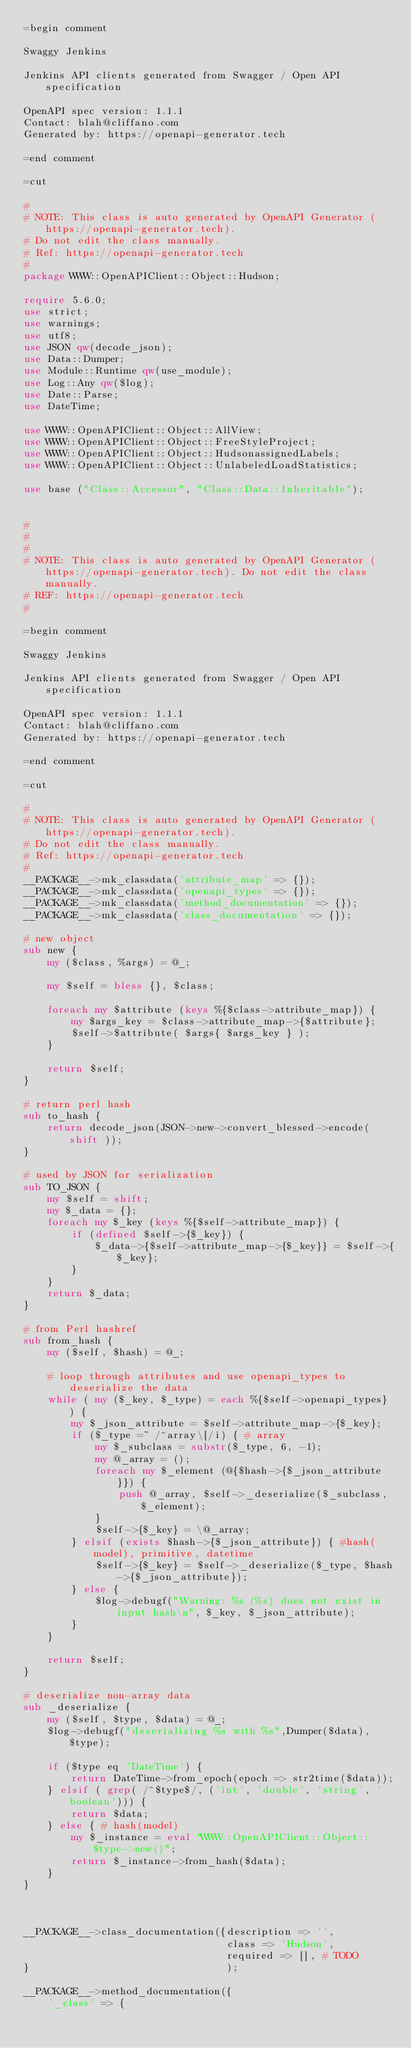<code> <loc_0><loc_0><loc_500><loc_500><_Perl_>=begin comment

Swaggy Jenkins

Jenkins API clients generated from Swagger / Open API specification

OpenAPI spec version: 1.1.1
Contact: blah@cliffano.com
Generated by: https://openapi-generator.tech

=end comment

=cut

#
# NOTE: This class is auto generated by OpenAPI Generator (https://openapi-generator.tech).
# Do not edit the class manually.
# Ref: https://openapi-generator.tech
#
package WWW::OpenAPIClient::Object::Hudson;

require 5.6.0;
use strict;
use warnings;
use utf8;
use JSON qw(decode_json);
use Data::Dumper;
use Module::Runtime qw(use_module);
use Log::Any qw($log);
use Date::Parse;
use DateTime;

use WWW::OpenAPIClient::Object::AllView;
use WWW::OpenAPIClient::Object::FreeStyleProject;
use WWW::OpenAPIClient::Object::HudsonassignedLabels;
use WWW::OpenAPIClient::Object::UnlabeledLoadStatistics;

use base ("Class::Accessor", "Class::Data::Inheritable");


#
#
#
# NOTE: This class is auto generated by OpenAPI Generator (https://openapi-generator.tech). Do not edit the class manually.
# REF: https://openapi-generator.tech
#

=begin comment

Swaggy Jenkins

Jenkins API clients generated from Swagger / Open API specification

OpenAPI spec version: 1.1.1
Contact: blah@cliffano.com
Generated by: https://openapi-generator.tech

=end comment

=cut

#
# NOTE: This class is auto generated by OpenAPI Generator (https://openapi-generator.tech).
# Do not edit the class manually.
# Ref: https://openapi-generator.tech
#
__PACKAGE__->mk_classdata('attribute_map' => {});
__PACKAGE__->mk_classdata('openapi_types' => {});
__PACKAGE__->mk_classdata('method_documentation' => {}); 
__PACKAGE__->mk_classdata('class_documentation' => {});

# new object
sub new { 
    my ($class, %args) = @_; 

	my $self = bless {}, $class;
	
	foreach my $attribute (keys %{$class->attribute_map}) {
		my $args_key = $class->attribute_map->{$attribute};
		$self->$attribute( $args{ $args_key } );
	}
	
	return $self;
}  

# return perl hash
sub to_hash {
    return decode_json(JSON->new->convert_blessed->encode( shift ));
}

# used by JSON for serialization
sub TO_JSON { 
    my $self = shift;
    my $_data = {};
    foreach my $_key (keys %{$self->attribute_map}) {
        if (defined $self->{$_key}) {
            $_data->{$self->attribute_map->{$_key}} = $self->{$_key};
        }
    }
    return $_data;
}

# from Perl hashref
sub from_hash {
    my ($self, $hash) = @_;

    # loop through attributes and use openapi_types to deserialize the data
    while ( my ($_key, $_type) = each %{$self->openapi_types} ) {
    	my $_json_attribute = $self->attribute_map->{$_key}; 
        if ($_type =~ /^array\[/i) { # array
            my $_subclass = substr($_type, 6, -1);
            my @_array = ();
            foreach my $_element (@{$hash->{$_json_attribute}}) {
                push @_array, $self->_deserialize($_subclass, $_element);
            }
            $self->{$_key} = \@_array;
        } elsif (exists $hash->{$_json_attribute}) { #hash(model), primitive, datetime
            $self->{$_key} = $self->_deserialize($_type, $hash->{$_json_attribute});
        } else {
        	$log->debugf("Warning: %s (%s) does not exist in input hash\n", $_key, $_json_attribute);
        }
    }
  
    return $self;
}

# deserialize non-array data
sub _deserialize {
    my ($self, $type, $data) = @_;
    $log->debugf("deserializing %s with %s",Dumper($data), $type);
        
    if ($type eq 'DateTime') {
        return DateTime->from_epoch(epoch => str2time($data));
    } elsif ( grep( /^$type$/, ('int', 'double', 'string', 'boolean'))) {
        return $data;
    } else { # hash(model)
        my $_instance = eval "WWW::OpenAPIClient::Object::$type->new()";
        return $_instance->from_hash($data);
    }
}



__PACKAGE__->class_documentation({description => '',
                                  class => 'Hudson',
                                  required => [], # TODO
}                                 );

__PACKAGE__->method_documentation({
    '_class' => {</code> 